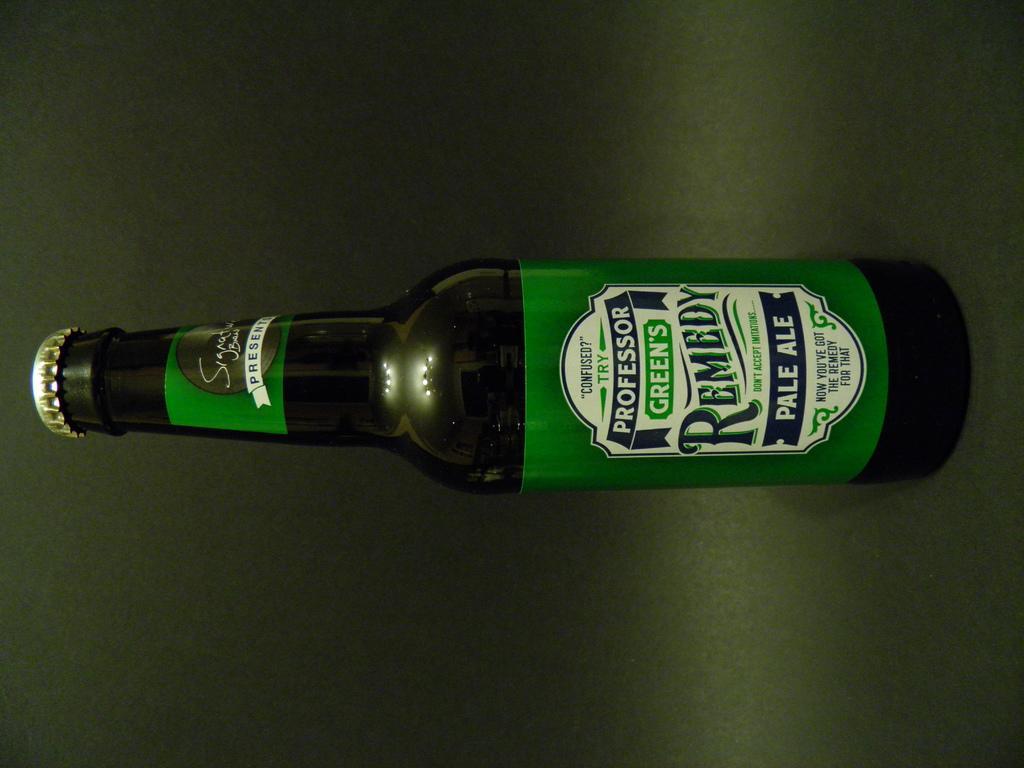Can you describe this image briefly? In this image we can see a bottle on the green colored surface, also we can see some text on the bottle. 